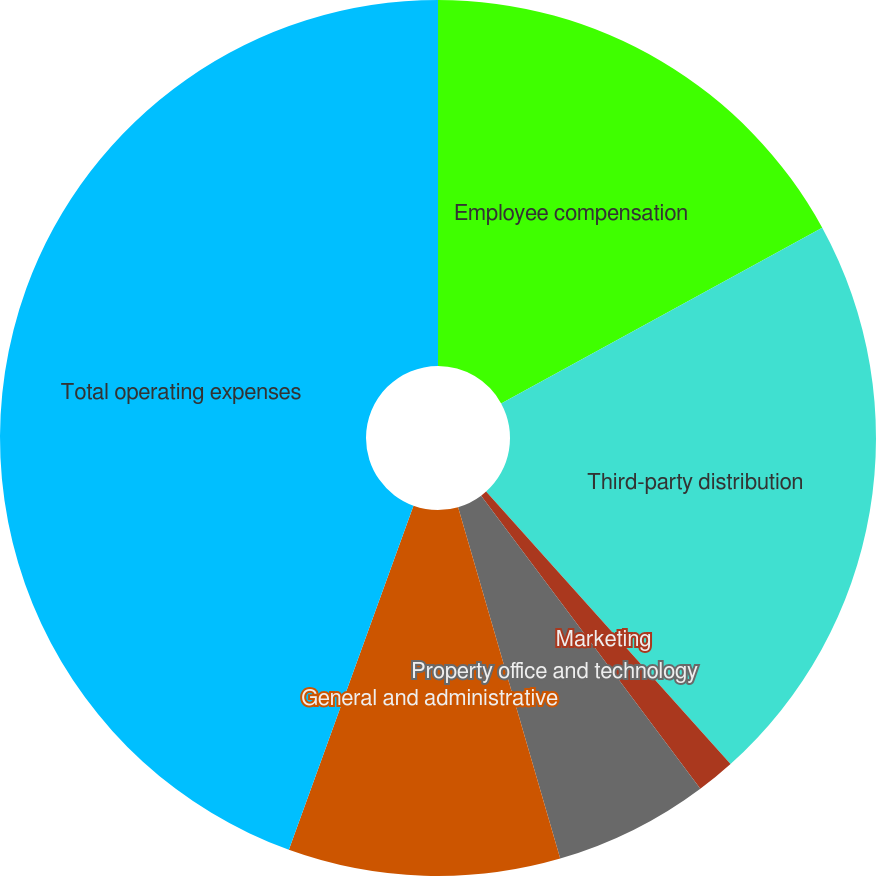<chart> <loc_0><loc_0><loc_500><loc_500><pie_chart><fcel>Employee compensation<fcel>Third-party distribution<fcel>Marketing<fcel>Property office and technology<fcel>General and administrative<fcel>Total operating expenses<nl><fcel>17.03%<fcel>21.33%<fcel>1.42%<fcel>5.72%<fcel>10.03%<fcel>44.47%<nl></chart> 